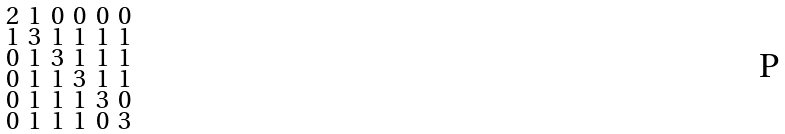<formula> <loc_0><loc_0><loc_500><loc_500>\begin{smallmatrix} 2 & 1 & 0 & 0 & 0 & 0 \\ 1 & 3 & 1 & 1 & 1 & 1 \\ 0 & 1 & 3 & 1 & 1 & 1 \\ 0 & 1 & 1 & 3 & 1 & 1 \\ 0 & 1 & 1 & 1 & 3 & 0 \\ 0 & 1 & 1 & 1 & 0 & 3 \end{smallmatrix}</formula> 